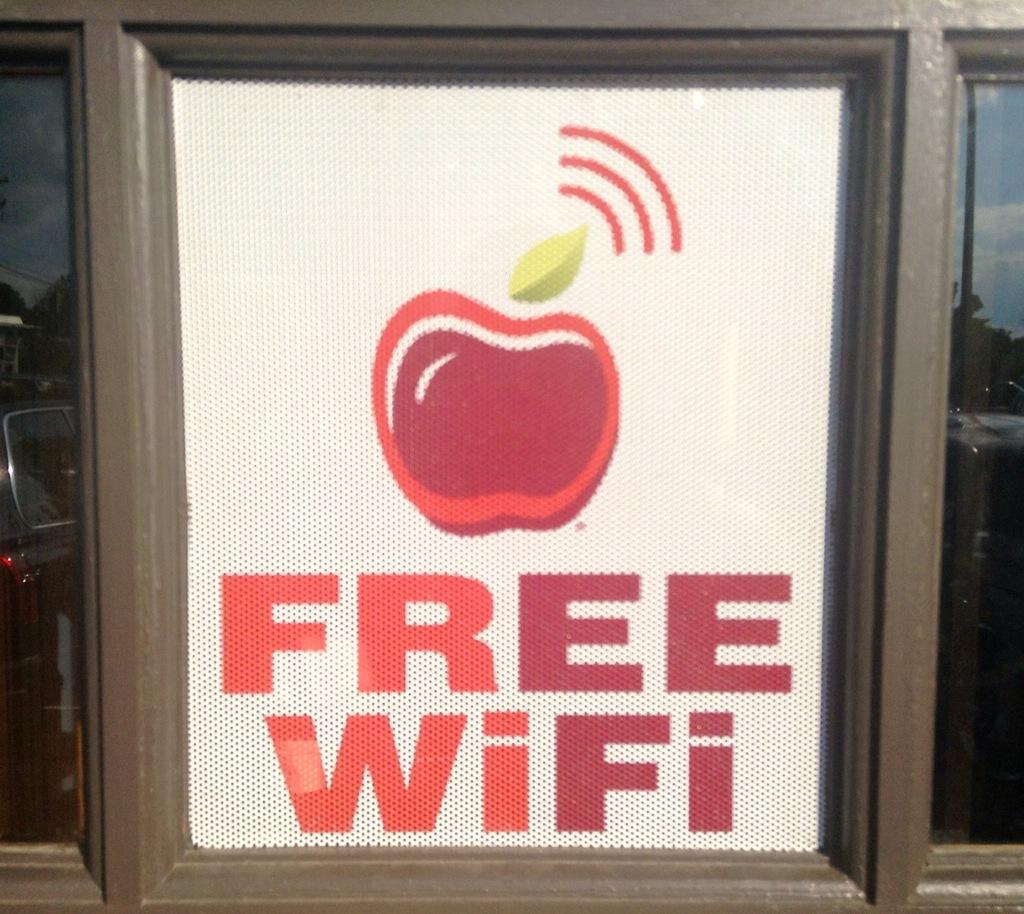Could you give a brief overview of what you see in this image? In the image I can see a glass on which there is a sticker. 